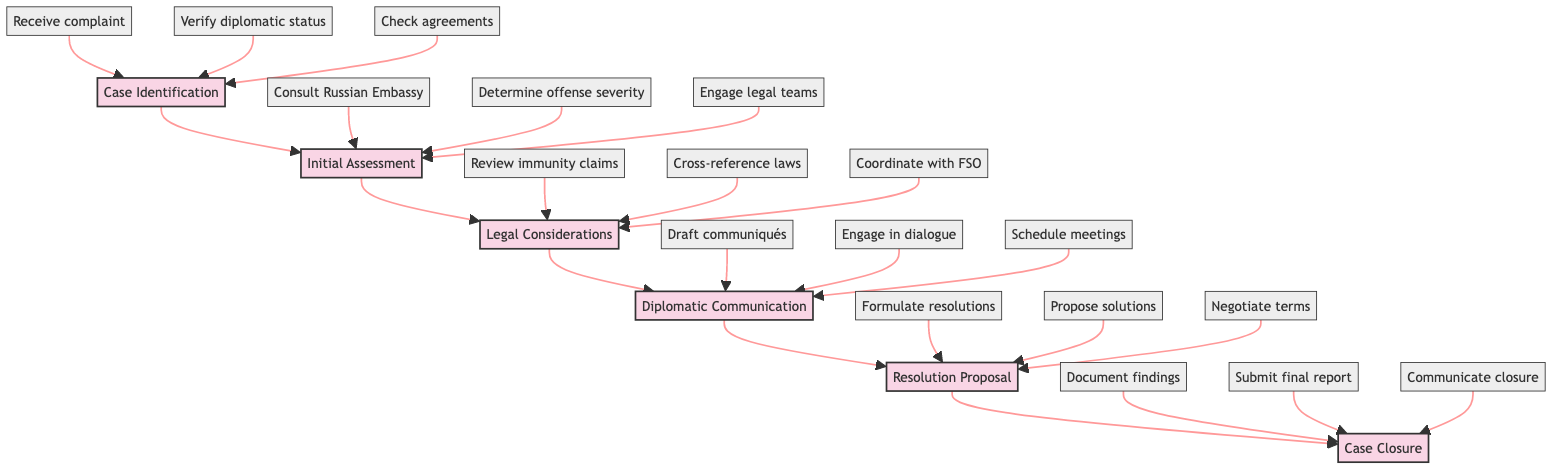What is the first stage in the diagram? The diagram starts with the stage labeled "Case Identification," which is the initial step in the clinical pathway.
Answer: Case Identification How many stages are there in total? There are six stages listed in the diagram, which are sequentially connected.
Answer: 6 Which step is part of the "Legal Considerations" stage? From the stage "Legal Considerations," one of the listed steps is "Review potential diplomatic immunity claims," indicating it belongs to this specific stage.
Answer: Review potential diplomatic immunity claims What follows the "Resolution Proposal" stage? Following the "Resolution Proposal" stage, the next stage is "Case Closure," as observed in the flow of the diagram.
Answer: Case Closure Which step is related to determining the offense's seriousness? The step "Determine seriousness of alleged offense" is specifically tied to the stage of "Initial Assessment" and addresses the evaluation of the offense's gravity.
Answer: Determine seriousness of alleged offense What is required before drafting official communiqués? Before drafting official communiqués, "Consult with the Russian Embassy" is a necessary action from the "Initial Assessment" stage that precedes the diplomatic communication activities.
Answer: Consult with the Russian Embassy Which organization should be coordinated with during "Legal Considerations"? "Coordinate with the Federal Protective Service (FSO)" is the step that indicates collaboration with this organization during the stage of "Legal Considerations."
Answer: Federal Protective Service (FSO) What type of solutions are proposed during the "Resolution Proposal" stage? During the "Resolution Proposal" stage, "Propose diplomatic solutions to mitigate legal and political fallout" is a key step that indicates the kind of solutions that will be considered.
Answer: Propose diplomatic solutions How is the flow from "Diplomatic Communication" to "Case Closure" structured? The flow proceeds from "Diplomatic Communication" directly to "Resolution Proposal," which subsequently leads to "Case Closure," establishing a clear sequence of stages from communication to resolution and closure.
Answer: Directly connected 